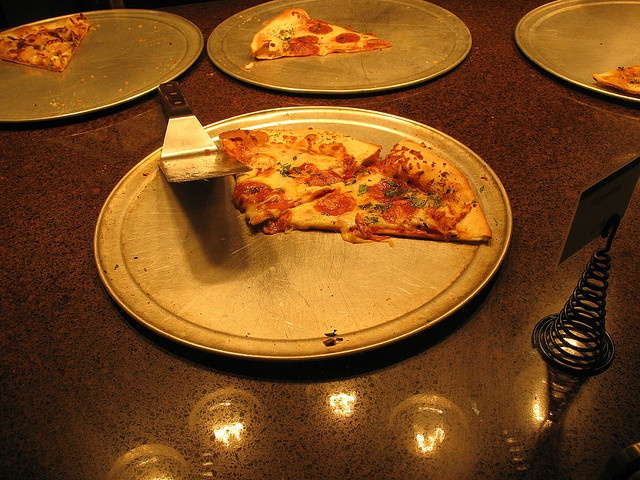Describe the objects in this image and their specific colors. I can see dining table in maroon, black, olive, and orange tones, pizza in black, orange, red, and brown tones, pizza in black, orange, red, brown, and gold tones, pizza in black, red, and maroon tones, and pizza in black, red, orange, and maroon tones in this image. 